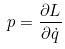<formula> <loc_0><loc_0><loc_500><loc_500>p = \frac { \partial L } { \partial \dot { q } }</formula> 